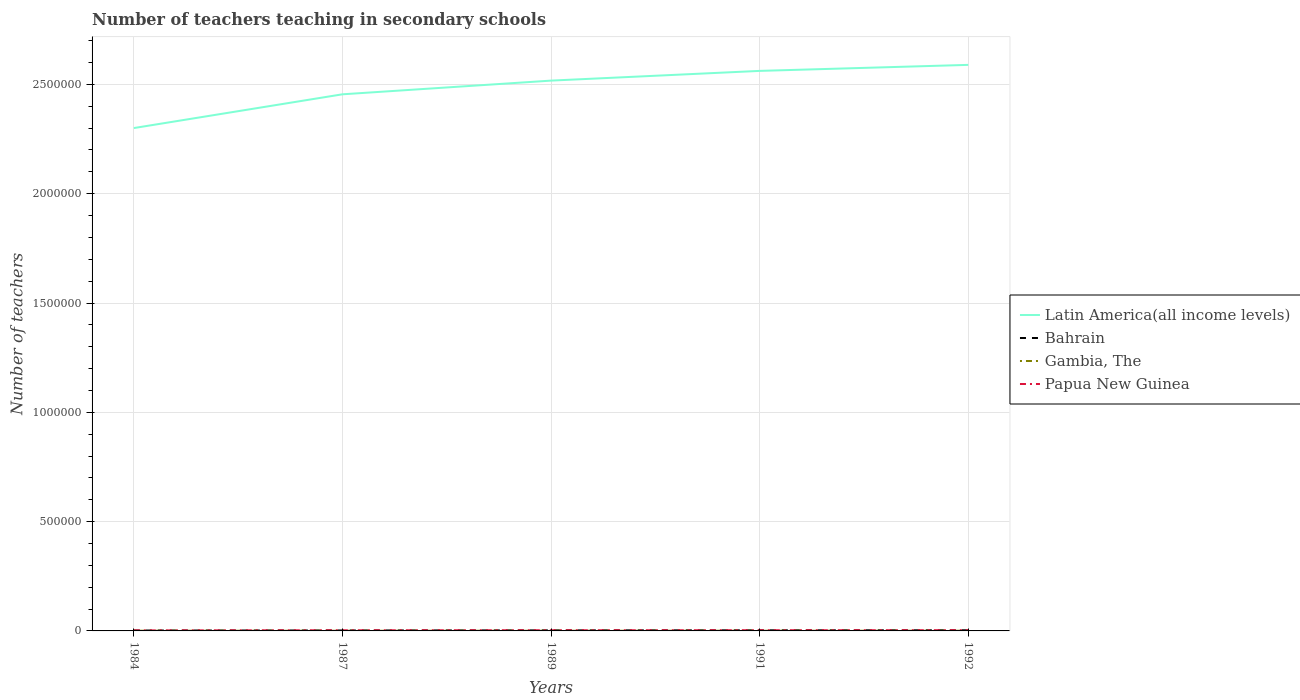How many different coloured lines are there?
Your answer should be compact. 4. Across all years, what is the maximum number of teachers teaching in secondary schools in Bahrain?
Your response must be concise. 1812. In which year was the number of teachers teaching in secondary schools in Papua New Guinea maximum?
Offer a terse response. 1984. What is the total number of teachers teaching in secondary schools in Papua New Guinea in the graph?
Provide a short and direct response. -679. What is the difference between the highest and the second highest number of teachers teaching in secondary schools in Gambia, The?
Your answer should be very brief. 171. What is the difference between the highest and the lowest number of teachers teaching in secondary schools in Papua New Guinea?
Offer a very short reply. 3. How many lines are there?
Your response must be concise. 4. What is the difference between two consecutive major ticks on the Y-axis?
Your answer should be compact. 5.00e+05. Are the values on the major ticks of Y-axis written in scientific E-notation?
Your answer should be very brief. No. Does the graph contain any zero values?
Your answer should be very brief. No. Does the graph contain grids?
Make the answer very short. Yes. How many legend labels are there?
Ensure brevity in your answer.  4. How are the legend labels stacked?
Your answer should be very brief. Vertical. What is the title of the graph?
Your response must be concise. Number of teachers teaching in secondary schools. Does "Zimbabwe" appear as one of the legend labels in the graph?
Offer a terse response. No. What is the label or title of the X-axis?
Provide a short and direct response. Years. What is the label or title of the Y-axis?
Your answer should be very brief. Number of teachers. What is the Number of teachers in Latin America(all income levels) in 1984?
Provide a short and direct response. 2.30e+06. What is the Number of teachers in Bahrain in 1984?
Keep it short and to the point. 1812. What is the Number of teachers in Gambia, The in 1984?
Make the answer very short. 829. What is the Number of teachers of Papua New Guinea in 1984?
Offer a very short reply. 2378. What is the Number of teachers in Latin America(all income levels) in 1987?
Ensure brevity in your answer.  2.45e+06. What is the Number of teachers in Bahrain in 1987?
Offer a terse response. 2061. What is the Number of teachers in Gambia, The in 1987?
Provide a short and direct response. 658. What is the Number of teachers of Papua New Guinea in 1987?
Provide a short and direct response. 2922. What is the Number of teachers of Latin America(all income levels) in 1989?
Ensure brevity in your answer.  2.52e+06. What is the Number of teachers of Bahrain in 1989?
Offer a very short reply. 2486. What is the Number of teachers of Gambia, The in 1989?
Your answer should be compact. 738. What is the Number of teachers in Papua New Guinea in 1989?
Keep it short and to the point. 3057. What is the Number of teachers in Latin America(all income levels) in 1991?
Your answer should be compact. 2.56e+06. What is the Number of teachers in Bahrain in 1991?
Provide a short and direct response. 2742. What is the Number of teachers in Gambia, The in 1991?
Ensure brevity in your answer.  756. What is the Number of teachers in Papua New Guinea in 1991?
Your answer should be compact. 3120. What is the Number of teachers in Latin America(all income levels) in 1992?
Offer a terse response. 2.59e+06. What is the Number of teachers of Bahrain in 1992?
Provide a short and direct response. 2927. What is the Number of teachers in Gambia, The in 1992?
Offer a very short reply. 777. What is the Number of teachers of Papua New Guinea in 1992?
Provide a succinct answer. 3293. Across all years, what is the maximum Number of teachers of Latin America(all income levels)?
Ensure brevity in your answer.  2.59e+06. Across all years, what is the maximum Number of teachers in Bahrain?
Your answer should be compact. 2927. Across all years, what is the maximum Number of teachers in Gambia, The?
Make the answer very short. 829. Across all years, what is the maximum Number of teachers in Papua New Guinea?
Give a very brief answer. 3293. Across all years, what is the minimum Number of teachers in Latin America(all income levels)?
Give a very brief answer. 2.30e+06. Across all years, what is the minimum Number of teachers of Bahrain?
Your answer should be very brief. 1812. Across all years, what is the minimum Number of teachers of Gambia, The?
Give a very brief answer. 658. Across all years, what is the minimum Number of teachers in Papua New Guinea?
Your answer should be compact. 2378. What is the total Number of teachers in Latin America(all income levels) in the graph?
Your response must be concise. 1.24e+07. What is the total Number of teachers in Bahrain in the graph?
Your response must be concise. 1.20e+04. What is the total Number of teachers in Gambia, The in the graph?
Make the answer very short. 3758. What is the total Number of teachers in Papua New Guinea in the graph?
Your answer should be very brief. 1.48e+04. What is the difference between the Number of teachers in Latin America(all income levels) in 1984 and that in 1987?
Your response must be concise. -1.54e+05. What is the difference between the Number of teachers of Bahrain in 1984 and that in 1987?
Provide a short and direct response. -249. What is the difference between the Number of teachers in Gambia, The in 1984 and that in 1987?
Make the answer very short. 171. What is the difference between the Number of teachers in Papua New Guinea in 1984 and that in 1987?
Offer a terse response. -544. What is the difference between the Number of teachers in Latin America(all income levels) in 1984 and that in 1989?
Your answer should be compact. -2.17e+05. What is the difference between the Number of teachers of Bahrain in 1984 and that in 1989?
Ensure brevity in your answer.  -674. What is the difference between the Number of teachers of Gambia, The in 1984 and that in 1989?
Give a very brief answer. 91. What is the difference between the Number of teachers of Papua New Guinea in 1984 and that in 1989?
Offer a terse response. -679. What is the difference between the Number of teachers of Latin America(all income levels) in 1984 and that in 1991?
Your response must be concise. -2.61e+05. What is the difference between the Number of teachers in Bahrain in 1984 and that in 1991?
Your answer should be very brief. -930. What is the difference between the Number of teachers of Gambia, The in 1984 and that in 1991?
Your response must be concise. 73. What is the difference between the Number of teachers in Papua New Guinea in 1984 and that in 1991?
Keep it short and to the point. -742. What is the difference between the Number of teachers of Latin America(all income levels) in 1984 and that in 1992?
Your response must be concise. -2.89e+05. What is the difference between the Number of teachers in Bahrain in 1984 and that in 1992?
Offer a very short reply. -1115. What is the difference between the Number of teachers of Gambia, The in 1984 and that in 1992?
Ensure brevity in your answer.  52. What is the difference between the Number of teachers of Papua New Guinea in 1984 and that in 1992?
Keep it short and to the point. -915. What is the difference between the Number of teachers of Latin America(all income levels) in 1987 and that in 1989?
Your answer should be very brief. -6.27e+04. What is the difference between the Number of teachers in Bahrain in 1987 and that in 1989?
Your response must be concise. -425. What is the difference between the Number of teachers in Gambia, The in 1987 and that in 1989?
Ensure brevity in your answer.  -80. What is the difference between the Number of teachers in Papua New Guinea in 1987 and that in 1989?
Make the answer very short. -135. What is the difference between the Number of teachers of Latin America(all income levels) in 1987 and that in 1991?
Your response must be concise. -1.07e+05. What is the difference between the Number of teachers in Bahrain in 1987 and that in 1991?
Make the answer very short. -681. What is the difference between the Number of teachers in Gambia, The in 1987 and that in 1991?
Provide a short and direct response. -98. What is the difference between the Number of teachers of Papua New Guinea in 1987 and that in 1991?
Provide a short and direct response. -198. What is the difference between the Number of teachers in Latin America(all income levels) in 1987 and that in 1992?
Ensure brevity in your answer.  -1.35e+05. What is the difference between the Number of teachers of Bahrain in 1987 and that in 1992?
Ensure brevity in your answer.  -866. What is the difference between the Number of teachers in Gambia, The in 1987 and that in 1992?
Your response must be concise. -119. What is the difference between the Number of teachers in Papua New Guinea in 1987 and that in 1992?
Keep it short and to the point. -371. What is the difference between the Number of teachers in Latin America(all income levels) in 1989 and that in 1991?
Provide a succinct answer. -4.44e+04. What is the difference between the Number of teachers of Bahrain in 1989 and that in 1991?
Provide a succinct answer. -256. What is the difference between the Number of teachers in Gambia, The in 1989 and that in 1991?
Make the answer very short. -18. What is the difference between the Number of teachers in Papua New Guinea in 1989 and that in 1991?
Your response must be concise. -63. What is the difference between the Number of teachers of Latin America(all income levels) in 1989 and that in 1992?
Your response must be concise. -7.20e+04. What is the difference between the Number of teachers of Bahrain in 1989 and that in 1992?
Keep it short and to the point. -441. What is the difference between the Number of teachers in Gambia, The in 1989 and that in 1992?
Your response must be concise. -39. What is the difference between the Number of teachers in Papua New Guinea in 1989 and that in 1992?
Make the answer very short. -236. What is the difference between the Number of teachers of Latin America(all income levels) in 1991 and that in 1992?
Your response must be concise. -2.76e+04. What is the difference between the Number of teachers of Bahrain in 1991 and that in 1992?
Keep it short and to the point. -185. What is the difference between the Number of teachers in Gambia, The in 1991 and that in 1992?
Make the answer very short. -21. What is the difference between the Number of teachers of Papua New Guinea in 1991 and that in 1992?
Make the answer very short. -173. What is the difference between the Number of teachers of Latin America(all income levels) in 1984 and the Number of teachers of Bahrain in 1987?
Give a very brief answer. 2.30e+06. What is the difference between the Number of teachers in Latin America(all income levels) in 1984 and the Number of teachers in Gambia, The in 1987?
Your response must be concise. 2.30e+06. What is the difference between the Number of teachers of Latin America(all income levels) in 1984 and the Number of teachers of Papua New Guinea in 1987?
Your answer should be compact. 2.30e+06. What is the difference between the Number of teachers in Bahrain in 1984 and the Number of teachers in Gambia, The in 1987?
Give a very brief answer. 1154. What is the difference between the Number of teachers in Bahrain in 1984 and the Number of teachers in Papua New Guinea in 1987?
Offer a terse response. -1110. What is the difference between the Number of teachers of Gambia, The in 1984 and the Number of teachers of Papua New Guinea in 1987?
Provide a succinct answer. -2093. What is the difference between the Number of teachers in Latin America(all income levels) in 1984 and the Number of teachers in Bahrain in 1989?
Give a very brief answer. 2.30e+06. What is the difference between the Number of teachers in Latin America(all income levels) in 1984 and the Number of teachers in Gambia, The in 1989?
Give a very brief answer. 2.30e+06. What is the difference between the Number of teachers in Latin America(all income levels) in 1984 and the Number of teachers in Papua New Guinea in 1989?
Offer a very short reply. 2.30e+06. What is the difference between the Number of teachers in Bahrain in 1984 and the Number of teachers in Gambia, The in 1989?
Your answer should be compact. 1074. What is the difference between the Number of teachers of Bahrain in 1984 and the Number of teachers of Papua New Guinea in 1989?
Make the answer very short. -1245. What is the difference between the Number of teachers in Gambia, The in 1984 and the Number of teachers in Papua New Guinea in 1989?
Ensure brevity in your answer.  -2228. What is the difference between the Number of teachers of Latin America(all income levels) in 1984 and the Number of teachers of Bahrain in 1991?
Offer a terse response. 2.30e+06. What is the difference between the Number of teachers in Latin America(all income levels) in 1984 and the Number of teachers in Gambia, The in 1991?
Your answer should be very brief. 2.30e+06. What is the difference between the Number of teachers in Latin America(all income levels) in 1984 and the Number of teachers in Papua New Guinea in 1991?
Your answer should be compact. 2.30e+06. What is the difference between the Number of teachers in Bahrain in 1984 and the Number of teachers in Gambia, The in 1991?
Your response must be concise. 1056. What is the difference between the Number of teachers of Bahrain in 1984 and the Number of teachers of Papua New Guinea in 1991?
Your response must be concise. -1308. What is the difference between the Number of teachers in Gambia, The in 1984 and the Number of teachers in Papua New Guinea in 1991?
Your answer should be very brief. -2291. What is the difference between the Number of teachers in Latin America(all income levels) in 1984 and the Number of teachers in Bahrain in 1992?
Offer a very short reply. 2.30e+06. What is the difference between the Number of teachers in Latin America(all income levels) in 1984 and the Number of teachers in Gambia, The in 1992?
Make the answer very short. 2.30e+06. What is the difference between the Number of teachers of Latin America(all income levels) in 1984 and the Number of teachers of Papua New Guinea in 1992?
Ensure brevity in your answer.  2.30e+06. What is the difference between the Number of teachers in Bahrain in 1984 and the Number of teachers in Gambia, The in 1992?
Your response must be concise. 1035. What is the difference between the Number of teachers in Bahrain in 1984 and the Number of teachers in Papua New Guinea in 1992?
Your response must be concise. -1481. What is the difference between the Number of teachers in Gambia, The in 1984 and the Number of teachers in Papua New Guinea in 1992?
Provide a short and direct response. -2464. What is the difference between the Number of teachers in Latin America(all income levels) in 1987 and the Number of teachers in Bahrain in 1989?
Give a very brief answer. 2.45e+06. What is the difference between the Number of teachers of Latin America(all income levels) in 1987 and the Number of teachers of Gambia, The in 1989?
Provide a succinct answer. 2.45e+06. What is the difference between the Number of teachers of Latin America(all income levels) in 1987 and the Number of teachers of Papua New Guinea in 1989?
Give a very brief answer. 2.45e+06. What is the difference between the Number of teachers in Bahrain in 1987 and the Number of teachers in Gambia, The in 1989?
Your answer should be very brief. 1323. What is the difference between the Number of teachers in Bahrain in 1987 and the Number of teachers in Papua New Guinea in 1989?
Offer a very short reply. -996. What is the difference between the Number of teachers of Gambia, The in 1987 and the Number of teachers of Papua New Guinea in 1989?
Keep it short and to the point. -2399. What is the difference between the Number of teachers in Latin America(all income levels) in 1987 and the Number of teachers in Bahrain in 1991?
Offer a terse response. 2.45e+06. What is the difference between the Number of teachers in Latin America(all income levels) in 1987 and the Number of teachers in Gambia, The in 1991?
Keep it short and to the point. 2.45e+06. What is the difference between the Number of teachers of Latin America(all income levels) in 1987 and the Number of teachers of Papua New Guinea in 1991?
Give a very brief answer. 2.45e+06. What is the difference between the Number of teachers of Bahrain in 1987 and the Number of teachers of Gambia, The in 1991?
Your response must be concise. 1305. What is the difference between the Number of teachers in Bahrain in 1987 and the Number of teachers in Papua New Guinea in 1991?
Make the answer very short. -1059. What is the difference between the Number of teachers in Gambia, The in 1987 and the Number of teachers in Papua New Guinea in 1991?
Keep it short and to the point. -2462. What is the difference between the Number of teachers of Latin America(all income levels) in 1987 and the Number of teachers of Bahrain in 1992?
Your response must be concise. 2.45e+06. What is the difference between the Number of teachers of Latin America(all income levels) in 1987 and the Number of teachers of Gambia, The in 1992?
Provide a succinct answer. 2.45e+06. What is the difference between the Number of teachers of Latin America(all income levels) in 1987 and the Number of teachers of Papua New Guinea in 1992?
Your answer should be very brief. 2.45e+06. What is the difference between the Number of teachers of Bahrain in 1987 and the Number of teachers of Gambia, The in 1992?
Give a very brief answer. 1284. What is the difference between the Number of teachers of Bahrain in 1987 and the Number of teachers of Papua New Guinea in 1992?
Your answer should be compact. -1232. What is the difference between the Number of teachers in Gambia, The in 1987 and the Number of teachers in Papua New Guinea in 1992?
Give a very brief answer. -2635. What is the difference between the Number of teachers in Latin America(all income levels) in 1989 and the Number of teachers in Bahrain in 1991?
Provide a short and direct response. 2.51e+06. What is the difference between the Number of teachers in Latin America(all income levels) in 1989 and the Number of teachers in Gambia, The in 1991?
Offer a very short reply. 2.52e+06. What is the difference between the Number of teachers of Latin America(all income levels) in 1989 and the Number of teachers of Papua New Guinea in 1991?
Give a very brief answer. 2.51e+06. What is the difference between the Number of teachers in Bahrain in 1989 and the Number of teachers in Gambia, The in 1991?
Give a very brief answer. 1730. What is the difference between the Number of teachers of Bahrain in 1989 and the Number of teachers of Papua New Guinea in 1991?
Your answer should be compact. -634. What is the difference between the Number of teachers in Gambia, The in 1989 and the Number of teachers in Papua New Guinea in 1991?
Your answer should be very brief. -2382. What is the difference between the Number of teachers of Latin America(all income levels) in 1989 and the Number of teachers of Bahrain in 1992?
Give a very brief answer. 2.51e+06. What is the difference between the Number of teachers of Latin America(all income levels) in 1989 and the Number of teachers of Gambia, The in 1992?
Offer a very short reply. 2.52e+06. What is the difference between the Number of teachers in Latin America(all income levels) in 1989 and the Number of teachers in Papua New Guinea in 1992?
Offer a very short reply. 2.51e+06. What is the difference between the Number of teachers in Bahrain in 1989 and the Number of teachers in Gambia, The in 1992?
Make the answer very short. 1709. What is the difference between the Number of teachers of Bahrain in 1989 and the Number of teachers of Papua New Guinea in 1992?
Your answer should be compact. -807. What is the difference between the Number of teachers of Gambia, The in 1989 and the Number of teachers of Papua New Guinea in 1992?
Ensure brevity in your answer.  -2555. What is the difference between the Number of teachers of Latin America(all income levels) in 1991 and the Number of teachers of Bahrain in 1992?
Your answer should be very brief. 2.56e+06. What is the difference between the Number of teachers of Latin America(all income levels) in 1991 and the Number of teachers of Gambia, The in 1992?
Your answer should be compact. 2.56e+06. What is the difference between the Number of teachers of Latin America(all income levels) in 1991 and the Number of teachers of Papua New Guinea in 1992?
Make the answer very short. 2.56e+06. What is the difference between the Number of teachers of Bahrain in 1991 and the Number of teachers of Gambia, The in 1992?
Offer a terse response. 1965. What is the difference between the Number of teachers of Bahrain in 1991 and the Number of teachers of Papua New Guinea in 1992?
Make the answer very short. -551. What is the difference between the Number of teachers in Gambia, The in 1991 and the Number of teachers in Papua New Guinea in 1992?
Provide a short and direct response. -2537. What is the average Number of teachers of Latin America(all income levels) per year?
Make the answer very short. 2.48e+06. What is the average Number of teachers of Bahrain per year?
Provide a short and direct response. 2405.6. What is the average Number of teachers in Gambia, The per year?
Provide a succinct answer. 751.6. What is the average Number of teachers in Papua New Guinea per year?
Your response must be concise. 2954. In the year 1984, what is the difference between the Number of teachers of Latin America(all income levels) and Number of teachers of Bahrain?
Give a very brief answer. 2.30e+06. In the year 1984, what is the difference between the Number of teachers in Latin America(all income levels) and Number of teachers in Gambia, The?
Make the answer very short. 2.30e+06. In the year 1984, what is the difference between the Number of teachers in Latin America(all income levels) and Number of teachers in Papua New Guinea?
Ensure brevity in your answer.  2.30e+06. In the year 1984, what is the difference between the Number of teachers of Bahrain and Number of teachers of Gambia, The?
Keep it short and to the point. 983. In the year 1984, what is the difference between the Number of teachers of Bahrain and Number of teachers of Papua New Guinea?
Offer a terse response. -566. In the year 1984, what is the difference between the Number of teachers of Gambia, The and Number of teachers of Papua New Guinea?
Your response must be concise. -1549. In the year 1987, what is the difference between the Number of teachers of Latin America(all income levels) and Number of teachers of Bahrain?
Your answer should be very brief. 2.45e+06. In the year 1987, what is the difference between the Number of teachers in Latin America(all income levels) and Number of teachers in Gambia, The?
Make the answer very short. 2.45e+06. In the year 1987, what is the difference between the Number of teachers of Latin America(all income levels) and Number of teachers of Papua New Guinea?
Ensure brevity in your answer.  2.45e+06. In the year 1987, what is the difference between the Number of teachers of Bahrain and Number of teachers of Gambia, The?
Provide a short and direct response. 1403. In the year 1987, what is the difference between the Number of teachers in Bahrain and Number of teachers in Papua New Guinea?
Ensure brevity in your answer.  -861. In the year 1987, what is the difference between the Number of teachers of Gambia, The and Number of teachers of Papua New Guinea?
Provide a short and direct response. -2264. In the year 1989, what is the difference between the Number of teachers of Latin America(all income levels) and Number of teachers of Bahrain?
Your answer should be compact. 2.51e+06. In the year 1989, what is the difference between the Number of teachers of Latin America(all income levels) and Number of teachers of Gambia, The?
Provide a succinct answer. 2.52e+06. In the year 1989, what is the difference between the Number of teachers in Latin America(all income levels) and Number of teachers in Papua New Guinea?
Ensure brevity in your answer.  2.51e+06. In the year 1989, what is the difference between the Number of teachers in Bahrain and Number of teachers in Gambia, The?
Offer a very short reply. 1748. In the year 1989, what is the difference between the Number of teachers in Bahrain and Number of teachers in Papua New Guinea?
Offer a very short reply. -571. In the year 1989, what is the difference between the Number of teachers of Gambia, The and Number of teachers of Papua New Guinea?
Make the answer very short. -2319. In the year 1991, what is the difference between the Number of teachers in Latin America(all income levels) and Number of teachers in Bahrain?
Keep it short and to the point. 2.56e+06. In the year 1991, what is the difference between the Number of teachers in Latin America(all income levels) and Number of teachers in Gambia, The?
Keep it short and to the point. 2.56e+06. In the year 1991, what is the difference between the Number of teachers of Latin America(all income levels) and Number of teachers of Papua New Guinea?
Your response must be concise. 2.56e+06. In the year 1991, what is the difference between the Number of teachers of Bahrain and Number of teachers of Gambia, The?
Provide a succinct answer. 1986. In the year 1991, what is the difference between the Number of teachers of Bahrain and Number of teachers of Papua New Guinea?
Your answer should be compact. -378. In the year 1991, what is the difference between the Number of teachers in Gambia, The and Number of teachers in Papua New Guinea?
Your answer should be very brief. -2364. In the year 1992, what is the difference between the Number of teachers in Latin America(all income levels) and Number of teachers in Bahrain?
Offer a terse response. 2.59e+06. In the year 1992, what is the difference between the Number of teachers in Latin America(all income levels) and Number of teachers in Gambia, The?
Ensure brevity in your answer.  2.59e+06. In the year 1992, what is the difference between the Number of teachers of Latin America(all income levels) and Number of teachers of Papua New Guinea?
Your response must be concise. 2.59e+06. In the year 1992, what is the difference between the Number of teachers of Bahrain and Number of teachers of Gambia, The?
Your answer should be very brief. 2150. In the year 1992, what is the difference between the Number of teachers in Bahrain and Number of teachers in Papua New Guinea?
Offer a very short reply. -366. In the year 1992, what is the difference between the Number of teachers of Gambia, The and Number of teachers of Papua New Guinea?
Your response must be concise. -2516. What is the ratio of the Number of teachers of Latin America(all income levels) in 1984 to that in 1987?
Your answer should be compact. 0.94. What is the ratio of the Number of teachers in Bahrain in 1984 to that in 1987?
Ensure brevity in your answer.  0.88. What is the ratio of the Number of teachers of Gambia, The in 1984 to that in 1987?
Give a very brief answer. 1.26. What is the ratio of the Number of teachers in Papua New Guinea in 1984 to that in 1987?
Make the answer very short. 0.81. What is the ratio of the Number of teachers of Latin America(all income levels) in 1984 to that in 1989?
Provide a short and direct response. 0.91. What is the ratio of the Number of teachers in Bahrain in 1984 to that in 1989?
Provide a short and direct response. 0.73. What is the ratio of the Number of teachers in Gambia, The in 1984 to that in 1989?
Your response must be concise. 1.12. What is the ratio of the Number of teachers in Papua New Guinea in 1984 to that in 1989?
Offer a very short reply. 0.78. What is the ratio of the Number of teachers in Latin America(all income levels) in 1984 to that in 1991?
Keep it short and to the point. 0.9. What is the ratio of the Number of teachers in Bahrain in 1984 to that in 1991?
Make the answer very short. 0.66. What is the ratio of the Number of teachers of Gambia, The in 1984 to that in 1991?
Your response must be concise. 1.1. What is the ratio of the Number of teachers in Papua New Guinea in 1984 to that in 1991?
Provide a short and direct response. 0.76. What is the ratio of the Number of teachers in Latin America(all income levels) in 1984 to that in 1992?
Your response must be concise. 0.89. What is the ratio of the Number of teachers in Bahrain in 1984 to that in 1992?
Your response must be concise. 0.62. What is the ratio of the Number of teachers in Gambia, The in 1984 to that in 1992?
Offer a terse response. 1.07. What is the ratio of the Number of teachers of Papua New Guinea in 1984 to that in 1992?
Provide a short and direct response. 0.72. What is the ratio of the Number of teachers of Latin America(all income levels) in 1987 to that in 1989?
Keep it short and to the point. 0.98. What is the ratio of the Number of teachers in Bahrain in 1987 to that in 1989?
Give a very brief answer. 0.83. What is the ratio of the Number of teachers in Gambia, The in 1987 to that in 1989?
Provide a short and direct response. 0.89. What is the ratio of the Number of teachers of Papua New Guinea in 1987 to that in 1989?
Provide a short and direct response. 0.96. What is the ratio of the Number of teachers in Latin America(all income levels) in 1987 to that in 1991?
Offer a terse response. 0.96. What is the ratio of the Number of teachers of Bahrain in 1987 to that in 1991?
Your response must be concise. 0.75. What is the ratio of the Number of teachers of Gambia, The in 1987 to that in 1991?
Offer a very short reply. 0.87. What is the ratio of the Number of teachers of Papua New Guinea in 1987 to that in 1991?
Your response must be concise. 0.94. What is the ratio of the Number of teachers in Latin America(all income levels) in 1987 to that in 1992?
Provide a short and direct response. 0.95. What is the ratio of the Number of teachers in Bahrain in 1987 to that in 1992?
Your answer should be compact. 0.7. What is the ratio of the Number of teachers of Gambia, The in 1987 to that in 1992?
Your response must be concise. 0.85. What is the ratio of the Number of teachers of Papua New Guinea in 1987 to that in 1992?
Make the answer very short. 0.89. What is the ratio of the Number of teachers in Latin America(all income levels) in 1989 to that in 1991?
Ensure brevity in your answer.  0.98. What is the ratio of the Number of teachers in Bahrain in 1989 to that in 1991?
Your answer should be compact. 0.91. What is the ratio of the Number of teachers of Gambia, The in 1989 to that in 1991?
Ensure brevity in your answer.  0.98. What is the ratio of the Number of teachers in Papua New Guinea in 1989 to that in 1991?
Provide a short and direct response. 0.98. What is the ratio of the Number of teachers of Latin America(all income levels) in 1989 to that in 1992?
Keep it short and to the point. 0.97. What is the ratio of the Number of teachers of Bahrain in 1989 to that in 1992?
Provide a short and direct response. 0.85. What is the ratio of the Number of teachers of Gambia, The in 1989 to that in 1992?
Offer a very short reply. 0.95. What is the ratio of the Number of teachers in Papua New Guinea in 1989 to that in 1992?
Provide a short and direct response. 0.93. What is the ratio of the Number of teachers of Latin America(all income levels) in 1991 to that in 1992?
Your response must be concise. 0.99. What is the ratio of the Number of teachers in Bahrain in 1991 to that in 1992?
Make the answer very short. 0.94. What is the ratio of the Number of teachers of Gambia, The in 1991 to that in 1992?
Offer a terse response. 0.97. What is the ratio of the Number of teachers in Papua New Guinea in 1991 to that in 1992?
Offer a terse response. 0.95. What is the difference between the highest and the second highest Number of teachers of Latin America(all income levels)?
Provide a succinct answer. 2.76e+04. What is the difference between the highest and the second highest Number of teachers in Bahrain?
Your response must be concise. 185. What is the difference between the highest and the second highest Number of teachers of Papua New Guinea?
Offer a terse response. 173. What is the difference between the highest and the lowest Number of teachers in Latin America(all income levels)?
Keep it short and to the point. 2.89e+05. What is the difference between the highest and the lowest Number of teachers of Bahrain?
Your answer should be compact. 1115. What is the difference between the highest and the lowest Number of teachers of Gambia, The?
Give a very brief answer. 171. What is the difference between the highest and the lowest Number of teachers of Papua New Guinea?
Offer a terse response. 915. 